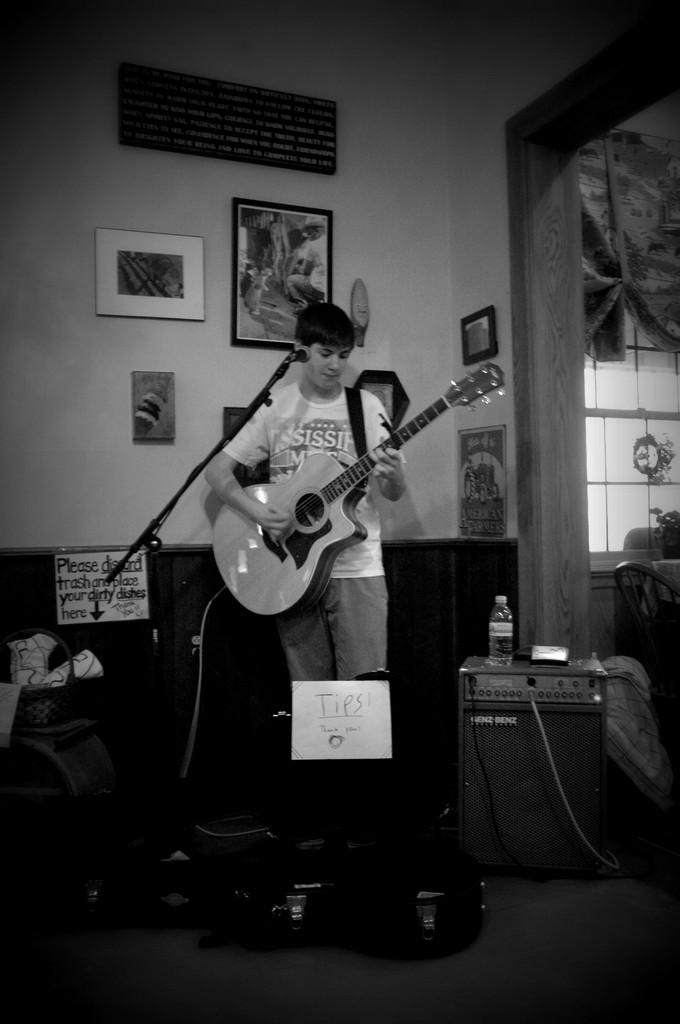What is the person in the image doing? The person is standing in front of a mic and holding a guitar. What object is the person using to communicate or perform? The person is using a mic to communicate or perform. What instrument is the person holding? The person is holding a guitar. What can be seen on the wall in the background? There are frames attached to the wall in the background. What is the name of the person offering a chance to play the guitar in the image? There is no person offering a chance to play the guitar in the image, nor is there any indication of a name. 